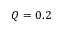Convert formula to latex. <formula><loc_0><loc_0><loc_500><loc_500>Q = 0 . 2</formula> 